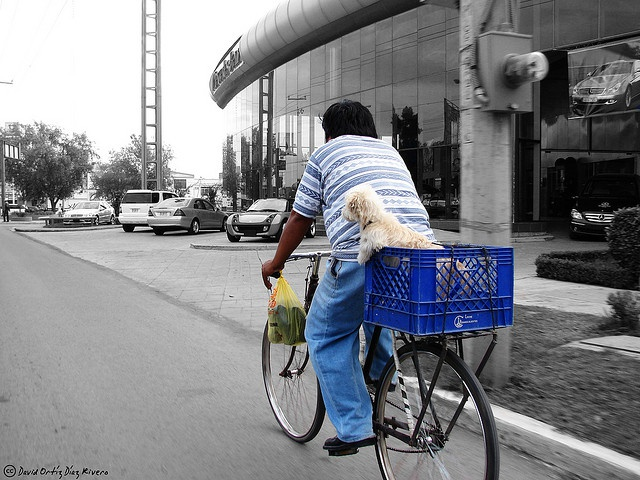Describe the objects in this image and their specific colors. I can see bicycle in white, darkgray, black, gray, and lightgray tones, people in white, black, lavender, blue, and gray tones, dog in white, ivory, darkgray, and tan tones, car in white, black, gray, darkgray, and lightgray tones, and car in white, gray, darkgray, black, and lightgray tones in this image. 